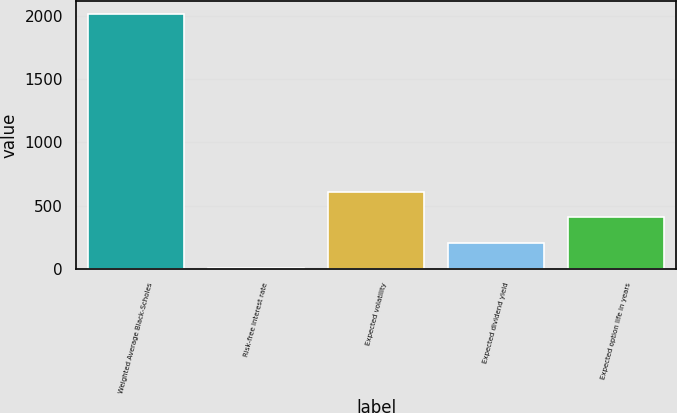Convert chart. <chart><loc_0><loc_0><loc_500><loc_500><bar_chart><fcel>Weighted Average Black-Scholes<fcel>Risk-free interest rate<fcel>Expected volatility<fcel>Expected dividend yield<fcel>Expected option life in years<nl><fcel>2018<fcel>2.6<fcel>607.22<fcel>204.14<fcel>405.68<nl></chart> 